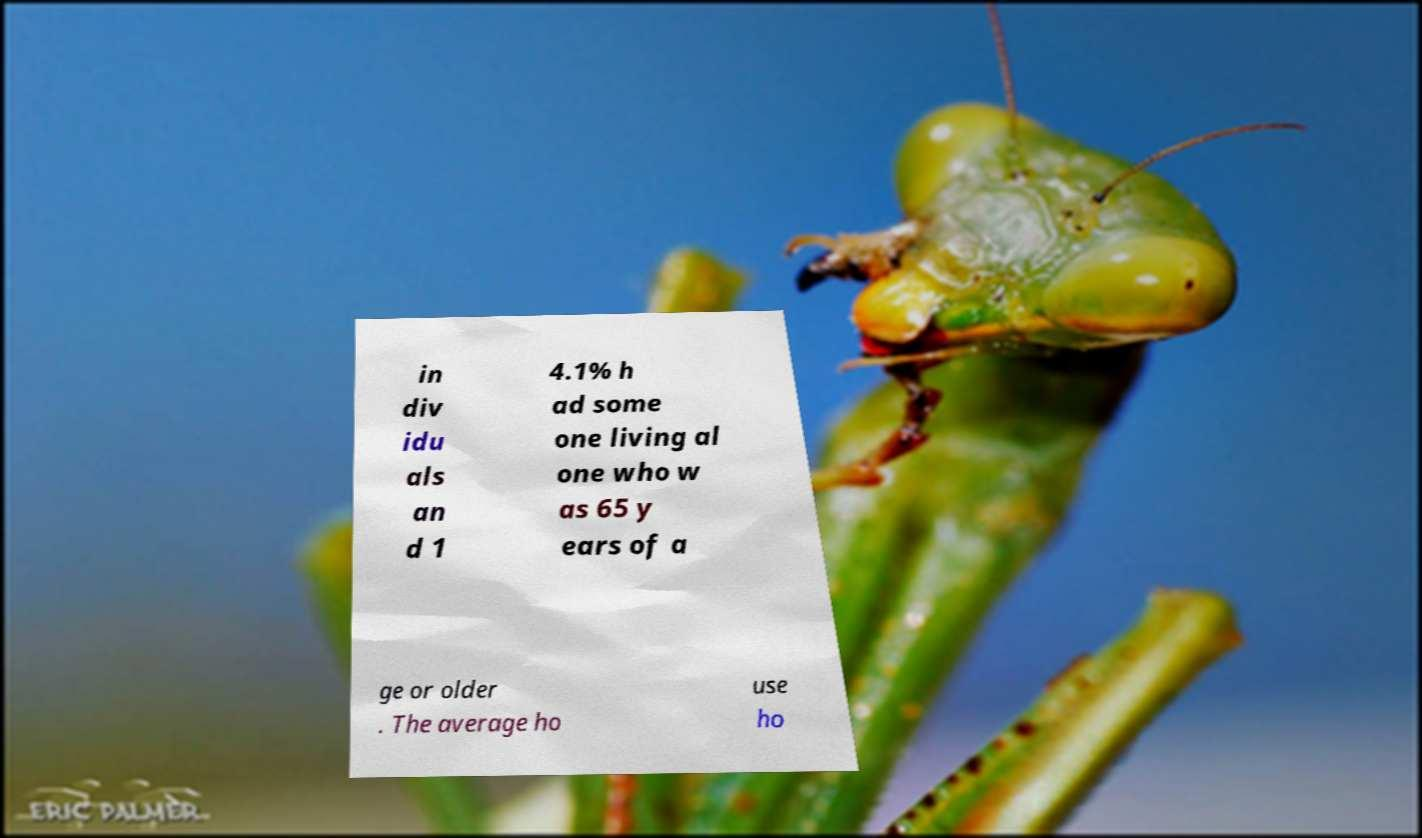Can you accurately transcribe the text from the provided image for me? in div idu als an d 1 4.1% h ad some one living al one who w as 65 y ears of a ge or older . The average ho use ho 